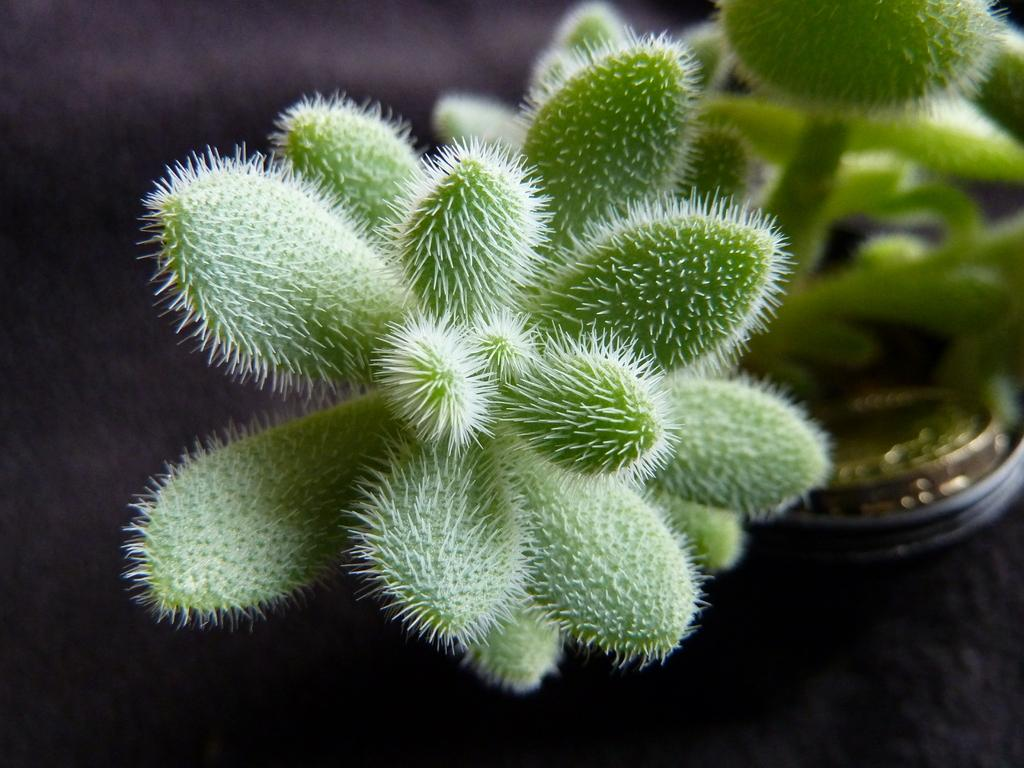What is the overall color scheme of the image? The background of the image is dark. What can be seen in the pot in the image? There is a cactus plant in the pot. On which side of the image is the pot located? The pot is on the right side of the image. What type of cushion is being used to support the grape in the image? There is no cushion or grape present in the image. 